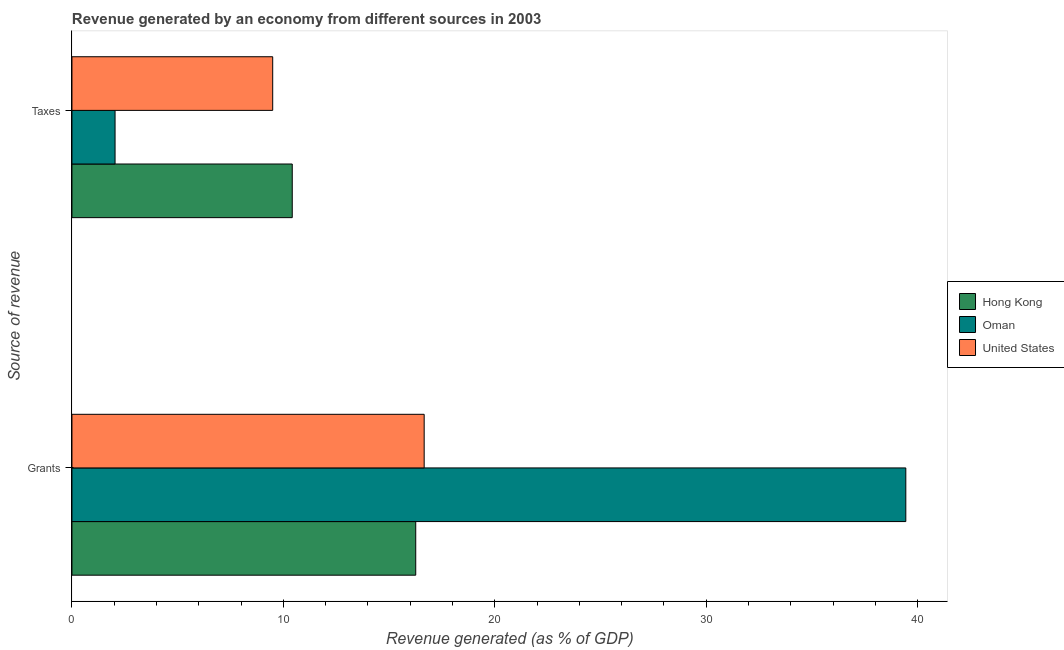How many different coloured bars are there?
Your answer should be very brief. 3. How many groups of bars are there?
Your response must be concise. 2. Are the number of bars on each tick of the Y-axis equal?
Provide a succinct answer. Yes. How many bars are there on the 1st tick from the bottom?
Give a very brief answer. 3. What is the label of the 2nd group of bars from the top?
Provide a succinct answer. Grants. What is the revenue generated by grants in Hong Kong?
Provide a short and direct response. 16.26. Across all countries, what is the maximum revenue generated by grants?
Offer a terse response. 39.44. Across all countries, what is the minimum revenue generated by taxes?
Ensure brevity in your answer.  2.04. In which country was the revenue generated by taxes maximum?
Keep it short and to the point. Hong Kong. In which country was the revenue generated by taxes minimum?
Offer a terse response. Oman. What is the total revenue generated by grants in the graph?
Offer a terse response. 72.36. What is the difference between the revenue generated by grants in Hong Kong and that in Oman?
Provide a short and direct response. -23.18. What is the difference between the revenue generated by grants in Oman and the revenue generated by taxes in Hong Kong?
Ensure brevity in your answer.  29.02. What is the average revenue generated by taxes per country?
Provide a short and direct response. 7.32. What is the difference between the revenue generated by taxes and revenue generated by grants in Oman?
Ensure brevity in your answer.  -37.4. What is the ratio of the revenue generated by taxes in Hong Kong to that in Oman?
Your answer should be compact. 5.11. Is the revenue generated by grants in Hong Kong less than that in United States?
Provide a short and direct response. Yes. In how many countries, is the revenue generated by taxes greater than the average revenue generated by taxes taken over all countries?
Ensure brevity in your answer.  2. What does the 2nd bar from the top in Grants represents?
Give a very brief answer. Oman. How many countries are there in the graph?
Ensure brevity in your answer.  3. Does the graph contain any zero values?
Give a very brief answer. No. Does the graph contain grids?
Your answer should be very brief. No. What is the title of the graph?
Your answer should be compact. Revenue generated by an economy from different sources in 2003. Does "St. Vincent and the Grenadines" appear as one of the legend labels in the graph?
Keep it short and to the point. No. What is the label or title of the X-axis?
Provide a succinct answer. Revenue generated (as % of GDP). What is the label or title of the Y-axis?
Keep it short and to the point. Source of revenue. What is the Revenue generated (as % of GDP) of Hong Kong in Grants?
Ensure brevity in your answer.  16.26. What is the Revenue generated (as % of GDP) of Oman in Grants?
Your answer should be very brief. 39.44. What is the Revenue generated (as % of GDP) of United States in Grants?
Keep it short and to the point. 16.66. What is the Revenue generated (as % of GDP) in Hong Kong in Taxes?
Your answer should be compact. 10.42. What is the Revenue generated (as % of GDP) of Oman in Taxes?
Ensure brevity in your answer.  2.04. What is the Revenue generated (as % of GDP) in United States in Taxes?
Provide a short and direct response. 9.49. Across all Source of revenue, what is the maximum Revenue generated (as % of GDP) in Hong Kong?
Your answer should be compact. 16.26. Across all Source of revenue, what is the maximum Revenue generated (as % of GDP) in Oman?
Your answer should be compact. 39.44. Across all Source of revenue, what is the maximum Revenue generated (as % of GDP) in United States?
Ensure brevity in your answer.  16.66. Across all Source of revenue, what is the minimum Revenue generated (as % of GDP) in Hong Kong?
Ensure brevity in your answer.  10.42. Across all Source of revenue, what is the minimum Revenue generated (as % of GDP) of Oman?
Offer a terse response. 2.04. Across all Source of revenue, what is the minimum Revenue generated (as % of GDP) in United States?
Give a very brief answer. 9.49. What is the total Revenue generated (as % of GDP) of Hong Kong in the graph?
Offer a terse response. 26.68. What is the total Revenue generated (as % of GDP) in Oman in the graph?
Offer a terse response. 41.48. What is the total Revenue generated (as % of GDP) in United States in the graph?
Your answer should be very brief. 26.15. What is the difference between the Revenue generated (as % of GDP) of Hong Kong in Grants and that in Taxes?
Your answer should be compact. 5.84. What is the difference between the Revenue generated (as % of GDP) in Oman in Grants and that in Taxes?
Ensure brevity in your answer.  37.4. What is the difference between the Revenue generated (as % of GDP) in United States in Grants and that in Taxes?
Ensure brevity in your answer.  7.16. What is the difference between the Revenue generated (as % of GDP) in Hong Kong in Grants and the Revenue generated (as % of GDP) in Oman in Taxes?
Provide a succinct answer. 14.22. What is the difference between the Revenue generated (as % of GDP) of Hong Kong in Grants and the Revenue generated (as % of GDP) of United States in Taxes?
Your answer should be very brief. 6.76. What is the difference between the Revenue generated (as % of GDP) of Oman in Grants and the Revenue generated (as % of GDP) of United States in Taxes?
Offer a very short reply. 29.94. What is the average Revenue generated (as % of GDP) in Hong Kong per Source of revenue?
Provide a succinct answer. 13.34. What is the average Revenue generated (as % of GDP) of Oman per Source of revenue?
Offer a very short reply. 20.74. What is the average Revenue generated (as % of GDP) in United States per Source of revenue?
Your response must be concise. 13.08. What is the difference between the Revenue generated (as % of GDP) in Hong Kong and Revenue generated (as % of GDP) in Oman in Grants?
Keep it short and to the point. -23.18. What is the difference between the Revenue generated (as % of GDP) of Hong Kong and Revenue generated (as % of GDP) of United States in Grants?
Provide a succinct answer. -0.4. What is the difference between the Revenue generated (as % of GDP) of Oman and Revenue generated (as % of GDP) of United States in Grants?
Offer a very short reply. 22.78. What is the difference between the Revenue generated (as % of GDP) in Hong Kong and Revenue generated (as % of GDP) in Oman in Taxes?
Offer a terse response. 8.38. What is the difference between the Revenue generated (as % of GDP) of Hong Kong and Revenue generated (as % of GDP) of United States in Taxes?
Make the answer very short. 0.92. What is the difference between the Revenue generated (as % of GDP) of Oman and Revenue generated (as % of GDP) of United States in Taxes?
Your response must be concise. -7.46. What is the ratio of the Revenue generated (as % of GDP) of Hong Kong in Grants to that in Taxes?
Your answer should be compact. 1.56. What is the ratio of the Revenue generated (as % of GDP) of Oman in Grants to that in Taxes?
Offer a terse response. 19.34. What is the ratio of the Revenue generated (as % of GDP) of United States in Grants to that in Taxes?
Ensure brevity in your answer.  1.75. What is the difference between the highest and the second highest Revenue generated (as % of GDP) of Hong Kong?
Offer a terse response. 5.84. What is the difference between the highest and the second highest Revenue generated (as % of GDP) in Oman?
Offer a terse response. 37.4. What is the difference between the highest and the second highest Revenue generated (as % of GDP) in United States?
Keep it short and to the point. 7.16. What is the difference between the highest and the lowest Revenue generated (as % of GDP) of Hong Kong?
Offer a terse response. 5.84. What is the difference between the highest and the lowest Revenue generated (as % of GDP) of Oman?
Keep it short and to the point. 37.4. What is the difference between the highest and the lowest Revenue generated (as % of GDP) in United States?
Provide a short and direct response. 7.16. 